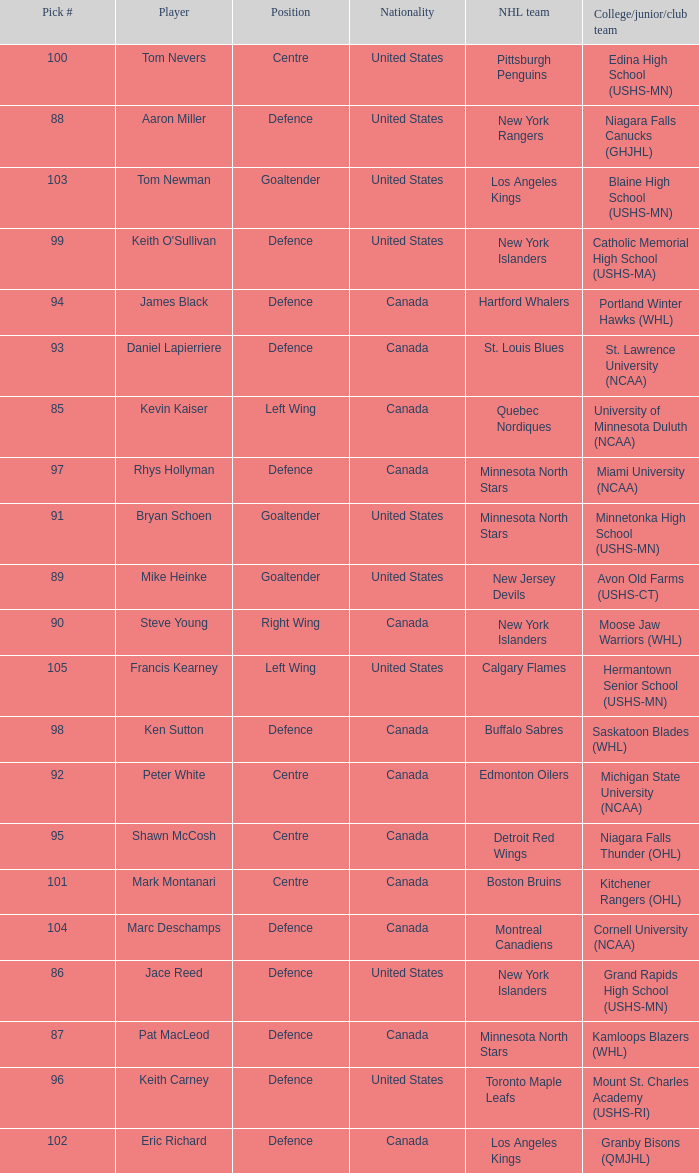What pick number was marc deschamps? 104.0. Parse the table in full. {'header': ['Pick #', 'Player', 'Position', 'Nationality', 'NHL team', 'College/junior/club team'], 'rows': [['100', 'Tom Nevers', 'Centre', 'United States', 'Pittsburgh Penguins', 'Edina High School (USHS-MN)'], ['88', 'Aaron Miller', 'Defence', 'United States', 'New York Rangers', 'Niagara Falls Canucks (GHJHL)'], ['103', 'Tom Newman', 'Goaltender', 'United States', 'Los Angeles Kings', 'Blaine High School (USHS-MN)'], ['99', "Keith O'Sullivan", 'Defence', 'United States', 'New York Islanders', 'Catholic Memorial High School (USHS-MA)'], ['94', 'James Black', 'Defence', 'Canada', 'Hartford Whalers', 'Portland Winter Hawks (WHL)'], ['93', 'Daniel Lapierriere', 'Defence', 'Canada', 'St. Louis Blues', 'St. Lawrence University (NCAA)'], ['85', 'Kevin Kaiser', 'Left Wing', 'Canada', 'Quebec Nordiques', 'University of Minnesota Duluth (NCAA)'], ['97', 'Rhys Hollyman', 'Defence', 'Canada', 'Minnesota North Stars', 'Miami University (NCAA)'], ['91', 'Bryan Schoen', 'Goaltender', 'United States', 'Minnesota North Stars', 'Minnetonka High School (USHS-MN)'], ['89', 'Mike Heinke', 'Goaltender', 'United States', 'New Jersey Devils', 'Avon Old Farms (USHS-CT)'], ['90', 'Steve Young', 'Right Wing', 'Canada', 'New York Islanders', 'Moose Jaw Warriors (WHL)'], ['105', 'Francis Kearney', 'Left Wing', 'United States', 'Calgary Flames', 'Hermantown Senior School (USHS-MN)'], ['98', 'Ken Sutton', 'Defence', 'Canada', 'Buffalo Sabres', 'Saskatoon Blades (WHL)'], ['92', 'Peter White', 'Centre', 'Canada', 'Edmonton Oilers', 'Michigan State University (NCAA)'], ['95', 'Shawn McCosh', 'Centre', 'Canada', 'Detroit Red Wings', 'Niagara Falls Thunder (OHL)'], ['101', 'Mark Montanari', 'Centre', 'Canada', 'Boston Bruins', 'Kitchener Rangers (OHL)'], ['104', 'Marc Deschamps', 'Defence', 'Canada', 'Montreal Canadiens', 'Cornell University (NCAA)'], ['86', 'Jace Reed', 'Defence', 'United States', 'New York Islanders', 'Grand Rapids High School (USHS-MN)'], ['87', 'Pat MacLeod', 'Defence', 'Canada', 'Minnesota North Stars', 'Kamloops Blazers (WHL)'], ['96', 'Keith Carney', 'Defence', 'United States', 'Toronto Maple Leafs', 'Mount St. Charles Academy (USHS-RI)'], ['102', 'Eric Richard', 'Defence', 'Canada', 'Los Angeles Kings', 'Granby Bisons (QMJHL)']]} 